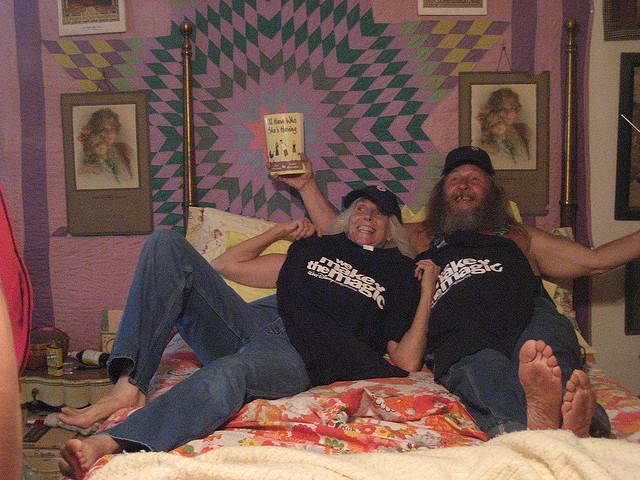How many people are in the photo?
Give a very brief answer. 2. 